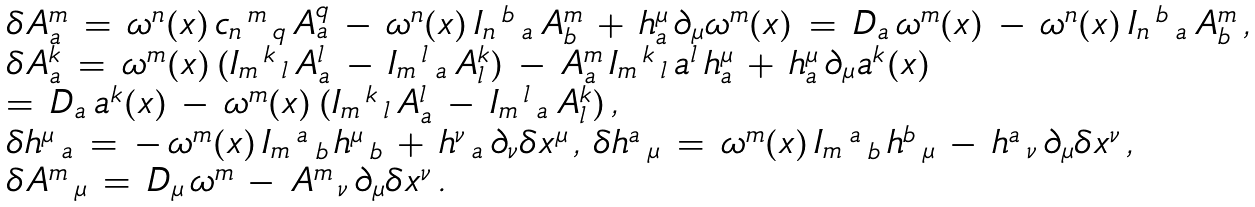<formula> <loc_0><loc_0><loc_500><loc_500>\begin{array} { l } { \delta A _ { a } ^ { m } \, = \, \omega ^ { n } ( x ) \, c _ { n } \, ^ { m } \, _ { q } \, A _ { a } ^ { q } \, - \, \omega ^ { n } ( x ) \, I _ { n } \, ^ { b } \, _ { a } \, A _ { b } ^ { m } \, + \, h ^ { \mu } _ { a } \, \partial _ { \mu } \omega ^ { m } ( x ) \, = \, D _ { a } \, \omega ^ { m } ( x ) \, - \, \omega ^ { n } ( x ) \, I _ { n } \, ^ { b } \, _ { a } \, A _ { b } ^ { m } \, , } \\ { \delta A _ { a } ^ { k } \, = \, \omega ^ { m } ( x ) \, ( I _ { m } \, ^ { k } \, _ { l } \, A _ { a } ^ { l } \, - \, I _ { m } \, ^ { l } \, _ { a } \, A _ { l } ^ { k } ) \, - \, A _ { a } ^ { m } \, I _ { m } \, ^ { k } \, _ { l } \, a ^ { l } \, h ^ { \mu } _ { a } \, + \, h ^ { \mu } _ { a } \, \partial _ { \mu } a ^ { k } ( x ) \, } \\ { = \, D _ { a } \, a ^ { k } ( x ) \, - \, \omega ^ { m } ( x ) \, ( I _ { m } \, ^ { k } \, _ { l } \, A _ { a } ^ { l } \, - \, I _ { m } \, ^ { l } \, _ { a } \, A _ { l } ^ { k } ) \, , } \\ { \delta h ^ { \mu } \, _ { a } \, = \, - \, \omega ^ { m } ( x ) \, I _ { m } \, ^ { a } \, _ { b } \, h ^ { \mu } \, _ { b } \, + \, h ^ { \nu } \, _ { a } \, \partial _ { \nu } \delta x ^ { \mu } \, , \, \delta h ^ { a } \, _ { \mu } \, = \, \omega ^ { m } ( x ) \, I _ { m } \, ^ { a } \, _ { b } \, h ^ { b } \, _ { \mu } \, - \, h ^ { a } \, _ { \nu } \, \partial _ { \mu } \delta x ^ { \nu } \, , \, } \\ { \delta A ^ { m } \, _ { \mu } \, = \, D _ { \mu } \, \omega ^ { m } \, - \, A ^ { m } \, _ { \nu } \, \partial _ { \mu } \delta x ^ { \nu } \, . } \end{array}</formula> 